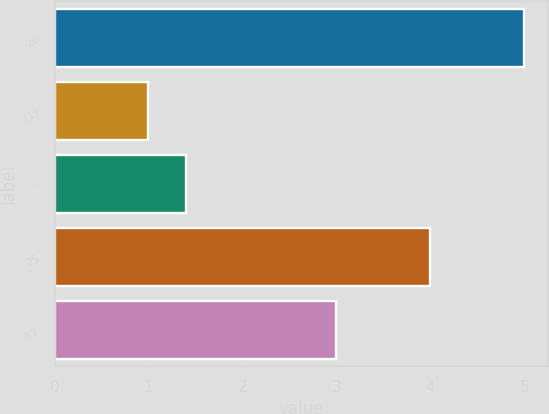<chart> <loc_0><loc_0><loc_500><loc_500><bar_chart><fcel>26<fcel>(1)<fcel>-<fcel>25<fcel>17<nl><fcel>5<fcel>1<fcel>1.4<fcel>4<fcel>3<nl></chart> 